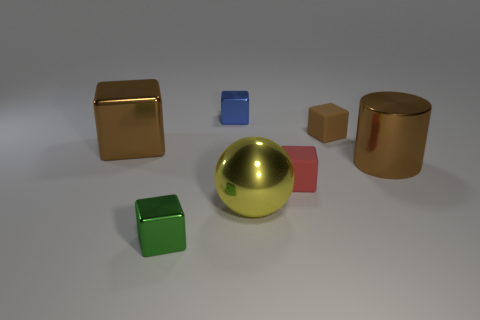There is a big brown shiny object that is to the right of the matte object that is behind the big brown metal cylinder; how many big metallic balls are behind it?
Keep it short and to the point. 0. Are there any blue things behind the cylinder?
Provide a short and direct response. Yes. What number of other cubes have the same material as the big cube?
Give a very brief answer. 2. How many objects are either yellow blocks or blue cubes?
Give a very brief answer. 1. Are any blue objects visible?
Give a very brief answer. Yes. What is the material of the small green thing in front of the large brown metallic thing to the left of the tiny shiny object that is behind the red cube?
Ensure brevity in your answer.  Metal. Is the number of red objects that are on the right side of the big brown cylinder less than the number of big brown metallic things?
Your answer should be very brief. Yes. What material is the block that is the same size as the yellow shiny thing?
Your response must be concise. Metal. There is a cube that is both left of the small brown matte block and right of the yellow shiny thing; what is its size?
Provide a short and direct response. Small. What size is the green thing that is the same shape as the small blue object?
Provide a short and direct response. Small. 